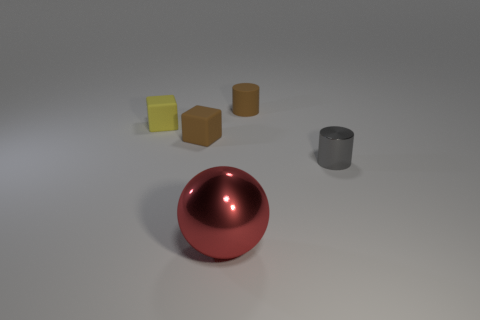Add 2 big red objects. How many objects exist? 7 Subtract all brown cylinders. How many cylinders are left? 1 Subtract all spheres. How many objects are left? 4 Subtract all small brown rubber objects. Subtract all tiny brown things. How many objects are left? 1 Add 5 big spheres. How many big spheres are left? 6 Add 4 small gray rubber blocks. How many small gray rubber blocks exist? 4 Subtract 0 blue cylinders. How many objects are left? 5 Subtract 2 cubes. How many cubes are left? 0 Subtract all brown balls. Subtract all brown cylinders. How many balls are left? 1 Subtract all yellow spheres. How many green blocks are left? 0 